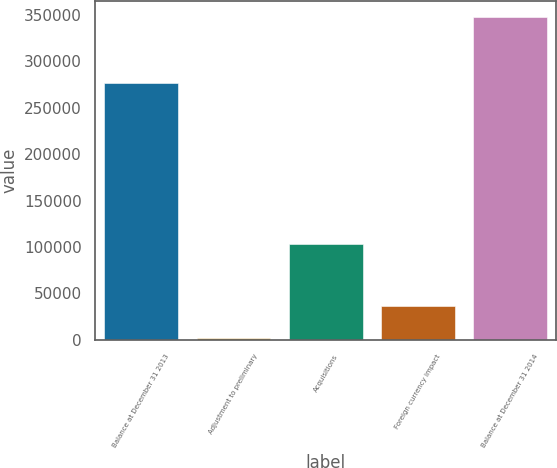<chart> <loc_0><loc_0><loc_500><loc_500><bar_chart><fcel>Balance at December 31 2013<fcel>Adjustment to preliminary<fcel>Acquisitions<fcel>Foreign currency impact<fcel>Balance at December 31 2014<nl><fcel>276769<fcel>2367<fcel>103347<fcel>36857.4<fcel>347271<nl></chart> 